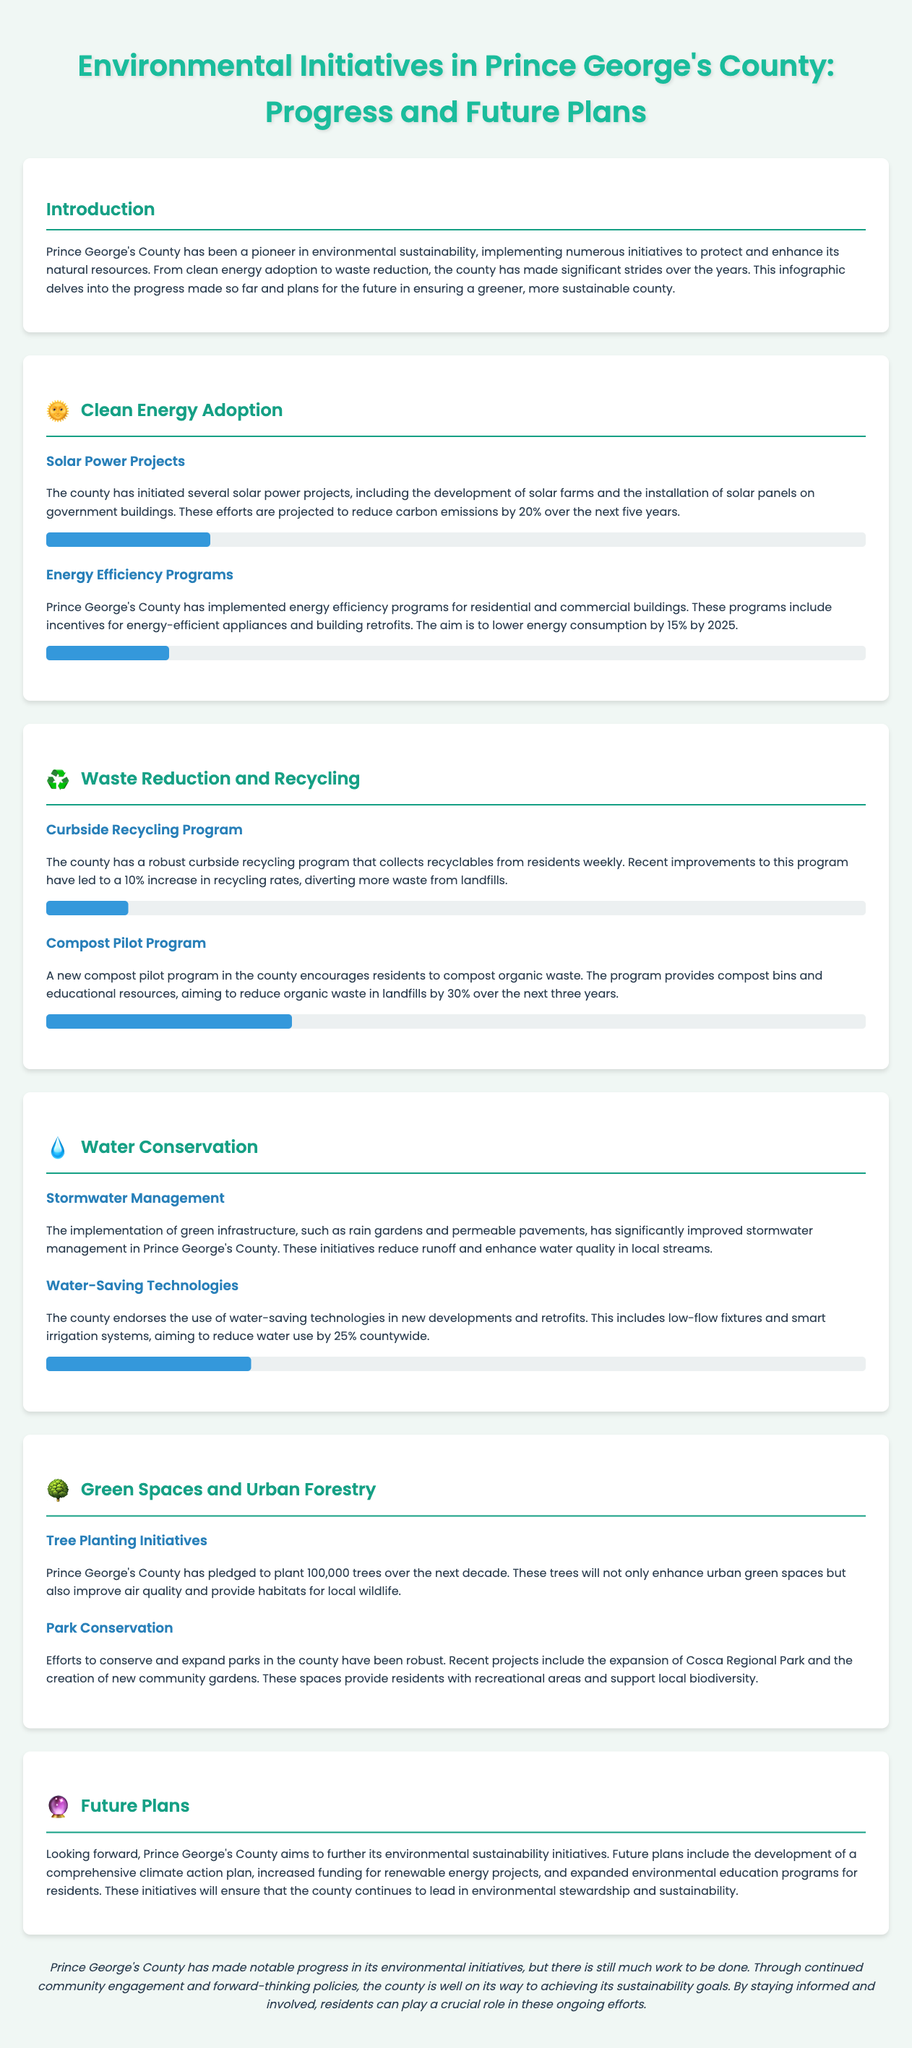what is the projected reduction in carbon emissions from solar power projects? The document states that these efforts are projected to reduce carbon emissions by 20% over the next five years.
Answer: 20% what is the goal for lowering energy consumption by 2025? The aim is to lower energy consumption by 15% by 2025 according to the energy efficiency programs described.
Answer: 15% what is the new compost pilot program's goal for reducing organic waste? The program aims to reduce organic waste in landfills by 30% over the next three years.
Answer: 30% how many trees does Prince George's County plan to plant over the next decade? The county has pledged to plant 100,000 trees over the next decade.
Answer: 100,000 what percentage increase in recycling rates has the curbside recycling program achieved? Recent improvements to this program have led to a 10% increase in recycling rates.
Answer: 10% what technologies does the county endorse for water conservation? The county endorses the use of water-saving technologies in new developments and retrofits.
Answer: water-saving technologies how has stormwater management been improved in the county? The implementation of green infrastructure, such as rain gardens and permeable pavements, has significantly improved stormwater management.
Answer: green infrastructure what is one of the future plans for environmental initiatives mentioned? Future plans include the development of a comprehensive climate action plan.
Answer: climate action plan what kind of educational initiatives are planned for the future in the county? The future plans include expanded environmental education programs for residents.
Answer: environmental education programs 